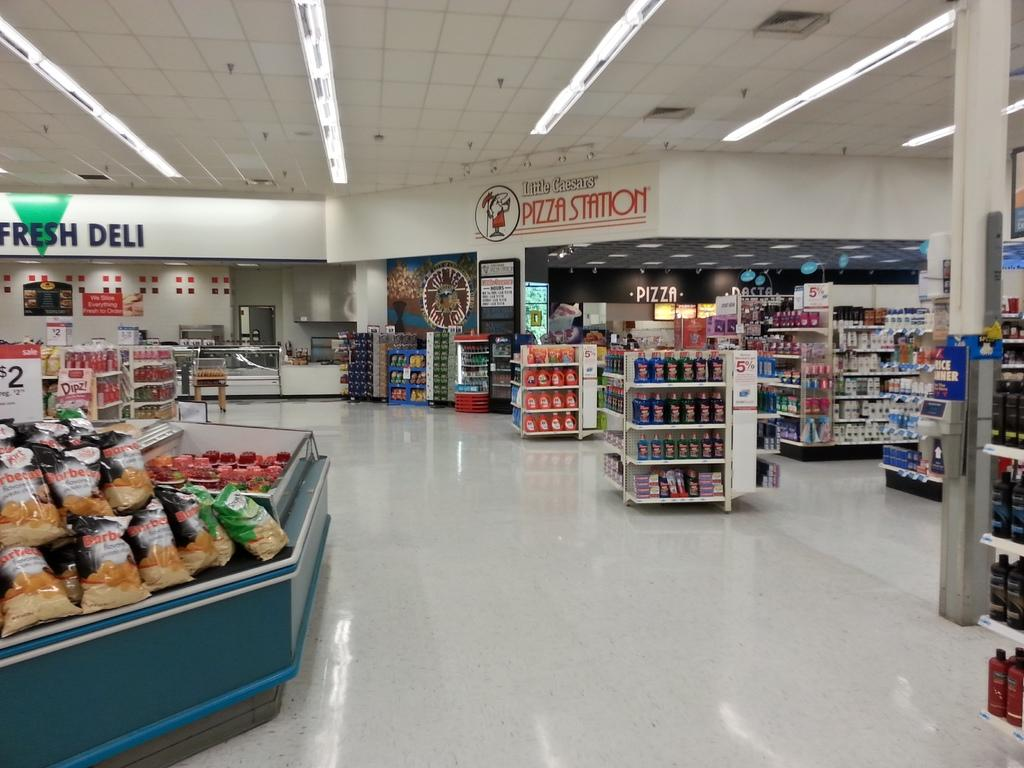<image>
Render a clear and concise summary of the photo. a pizza station that is located in a store 